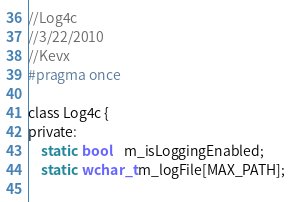<code> <loc_0><loc_0><loc_500><loc_500><_C_>//Log4c
//3/22/2010
//Kevx
#pragma once

class Log4c {
private:
	static  bool	m_isLoggingEnabled;
	static  wchar_t m_logFile[MAX_PATH];
	</code> 